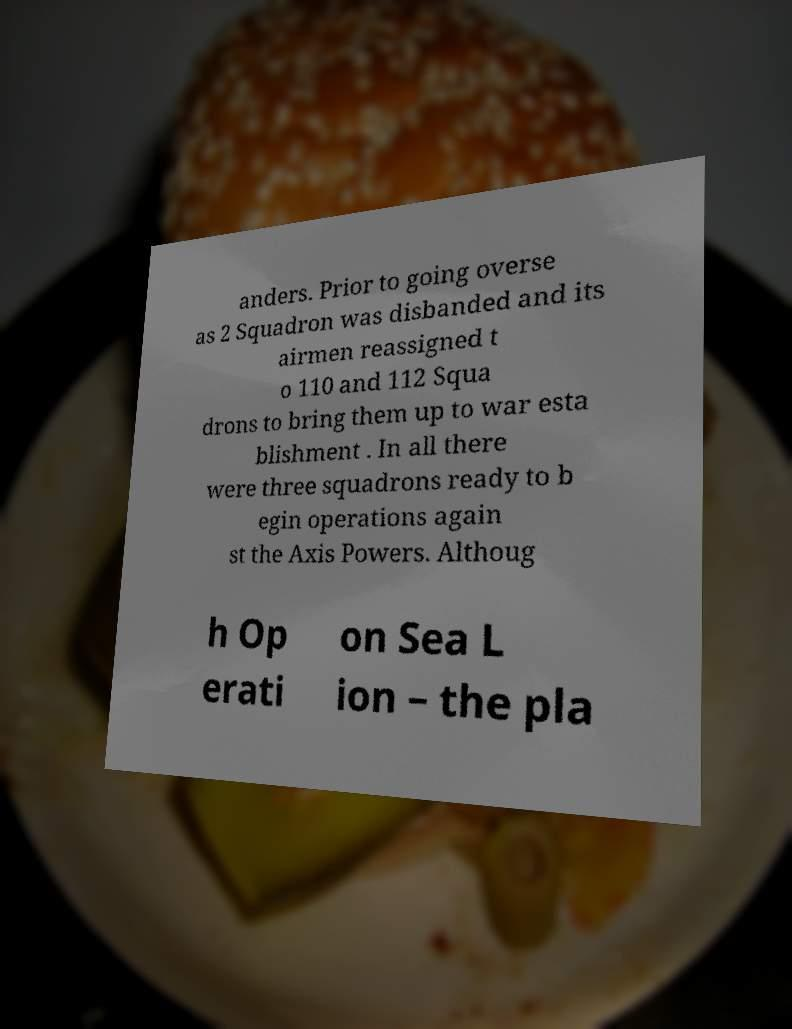Please read and relay the text visible in this image. What does it say? anders. Prior to going overse as 2 Squadron was disbanded and its airmen reassigned t o 110 and 112 Squa drons to bring them up to war esta blishment . In all there were three squadrons ready to b egin operations again st the Axis Powers. Althoug h Op erati on Sea L ion – the pla 